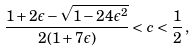<formula> <loc_0><loc_0><loc_500><loc_500>\frac { 1 + 2 \epsilon - \sqrt { 1 - 2 4 \epsilon ^ { 2 } } } { 2 ( 1 + 7 \epsilon ) } < c < \frac { 1 } { 2 } \, ,</formula> 